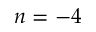<formula> <loc_0><loc_0><loc_500><loc_500>n = - 4</formula> 